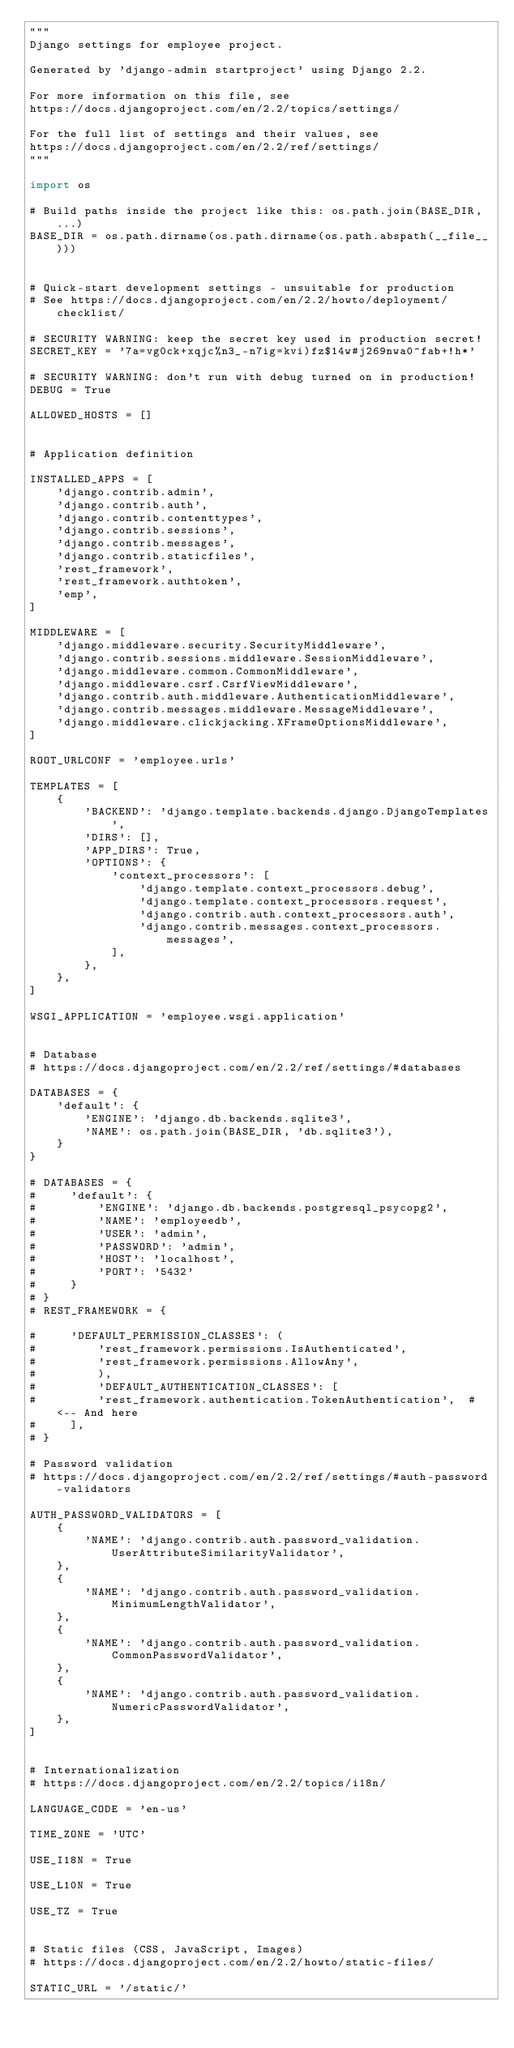<code> <loc_0><loc_0><loc_500><loc_500><_Python_>"""
Django settings for employee project.

Generated by 'django-admin startproject' using Django 2.2.

For more information on this file, see
https://docs.djangoproject.com/en/2.2/topics/settings/

For the full list of settings and their values, see
https://docs.djangoproject.com/en/2.2/ref/settings/
"""

import os

# Build paths inside the project like this: os.path.join(BASE_DIR, ...)
BASE_DIR = os.path.dirname(os.path.dirname(os.path.abspath(__file__)))


# Quick-start development settings - unsuitable for production
# See https://docs.djangoproject.com/en/2.2/howto/deployment/checklist/

# SECURITY WARNING: keep the secret key used in production secret!
SECRET_KEY = '7a=vg0ck+xqjc%n3_-n7ig=kvi)fz$14w#j269nwa0^fab+!h*'

# SECURITY WARNING: don't run with debug turned on in production!
DEBUG = True

ALLOWED_HOSTS = []


# Application definition

INSTALLED_APPS = [
    'django.contrib.admin',
    'django.contrib.auth',
    'django.contrib.contenttypes',
    'django.contrib.sessions',
    'django.contrib.messages',
    'django.contrib.staticfiles',
    'rest_framework',
    'rest_framework.authtoken',
    'emp',
]

MIDDLEWARE = [
    'django.middleware.security.SecurityMiddleware',
    'django.contrib.sessions.middleware.SessionMiddleware',
    'django.middleware.common.CommonMiddleware',
    'django.middleware.csrf.CsrfViewMiddleware',
    'django.contrib.auth.middleware.AuthenticationMiddleware',
    'django.contrib.messages.middleware.MessageMiddleware',
    'django.middleware.clickjacking.XFrameOptionsMiddleware',
]

ROOT_URLCONF = 'employee.urls'

TEMPLATES = [
    {
        'BACKEND': 'django.template.backends.django.DjangoTemplates',
        'DIRS': [],
        'APP_DIRS': True,
        'OPTIONS': {
            'context_processors': [
                'django.template.context_processors.debug',
                'django.template.context_processors.request',
                'django.contrib.auth.context_processors.auth',
                'django.contrib.messages.context_processors.messages',
            ],
        },
    },
]

WSGI_APPLICATION = 'employee.wsgi.application'


# Database
# https://docs.djangoproject.com/en/2.2/ref/settings/#databases

DATABASES = {
    'default': {
        'ENGINE': 'django.db.backends.sqlite3',
        'NAME': os.path.join(BASE_DIR, 'db.sqlite3'),
    }
}

# DATABASES = {
#     'default': {
#         'ENGINE': 'django.db.backends.postgresql_psycopg2',
#         'NAME': 'employeedb',
#         'USER': 'admin',
#         'PASSWORD': 'admin',
#         'HOST': 'localhost',
#         'PORT': '5432'
#     }
# }
# REST_FRAMEWORK = {
    
#     'DEFAULT_PERMISSION_CLASSES': (
#         'rest_framework.permissions.IsAuthenticated',
#         'rest_framework.permissions.AllowAny',
#         ),
#         'DEFAULT_AUTHENTICATION_CLASSES': [
#         'rest_framework.authentication.TokenAuthentication',  # <-- And here
#     ],
# }

# Password validation
# https://docs.djangoproject.com/en/2.2/ref/settings/#auth-password-validators

AUTH_PASSWORD_VALIDATORS = [
    {
        'NAME': 'django.contrib.auth.password_validation.UserAttributeSimilarityValidator',
    },
    {
        'NAME': 'django.contrib.auth.password_validation.MinimumLengthValidator',
    },
    {
        'NAME': 'django.contrib.auth.password_validation.CommonPasswordValidator',
    },
    {
        'NAME': 'django.contrib.auth.password_validation.NumericPasswordValidator',
    },
]


# Internationalization
# https://docs.djangoproject.com/en/2.2/topics/i18n/

LANGUAGE_CODE = 'en-us'

TIME_ZONE = 'UTC'

USE_I18N = True

USE_L10N = True

USE_TZ = True


# Static files (CSS, JavaScript, Images)
# https://docs.djangoproject.com/en/2.2/howto/static-files/

STATIC_URL = '/static/'
</code> 